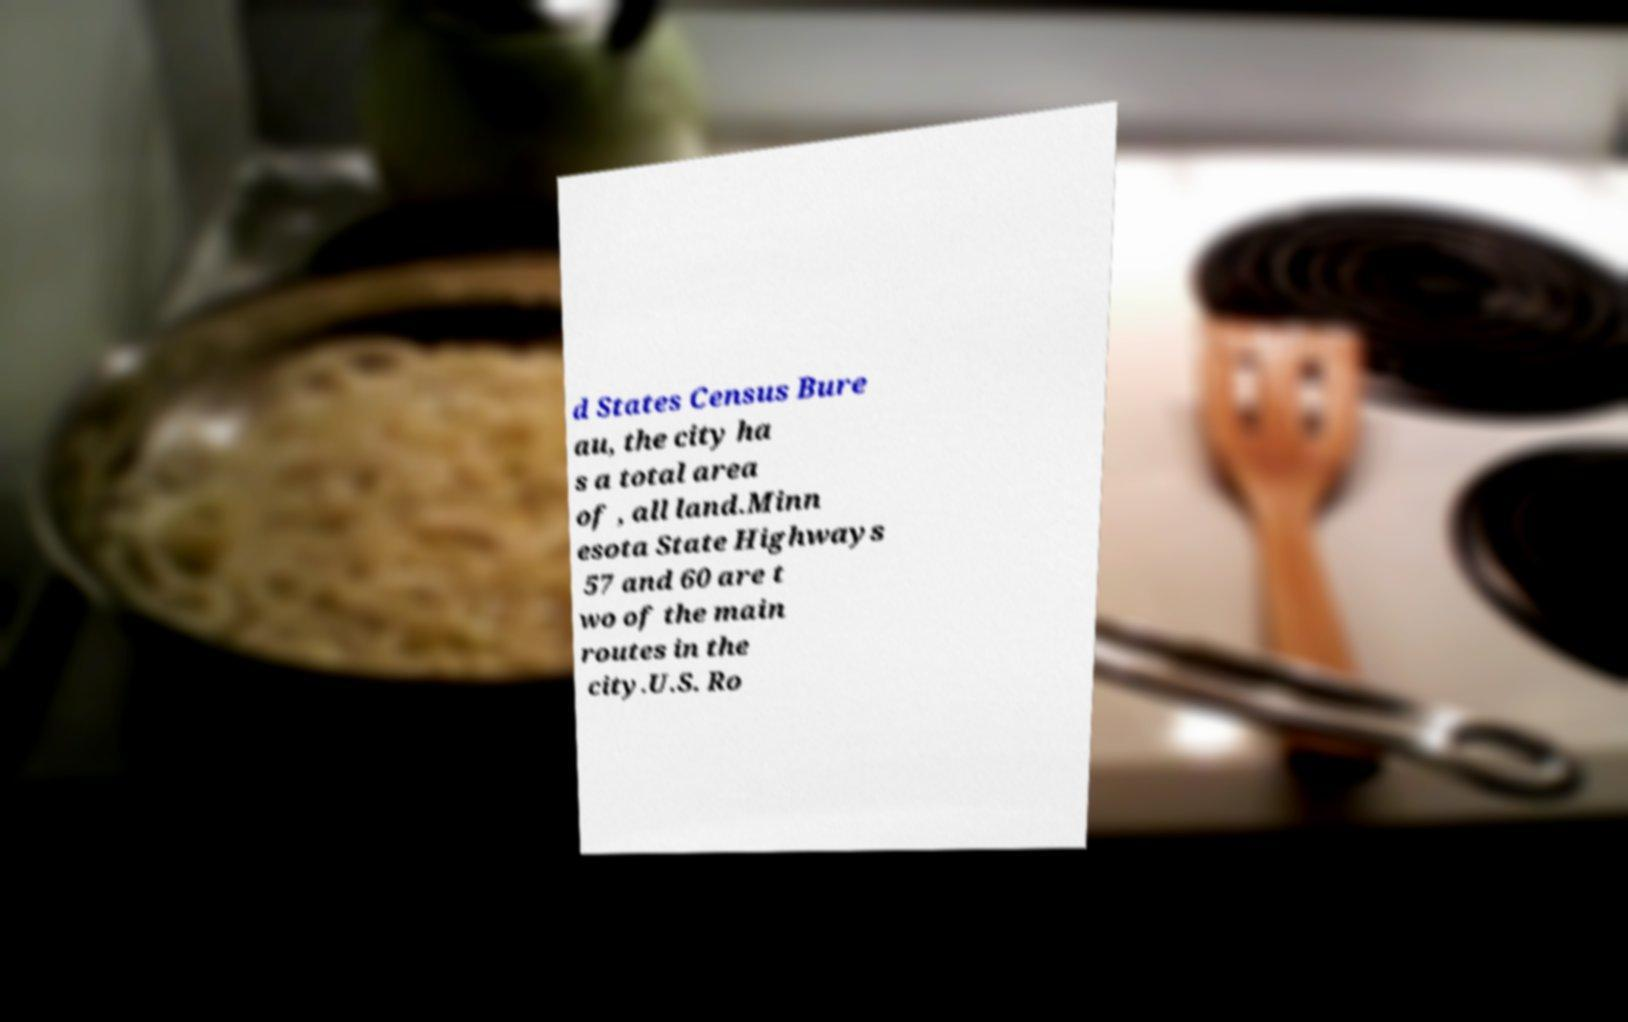Could you extract and type out the text from this image? d States Census Bure au, the city ha s a total area of , all land.Minn esota State Highways 57 and 60 are t wo of the main routes in the city.U.S. Ro 